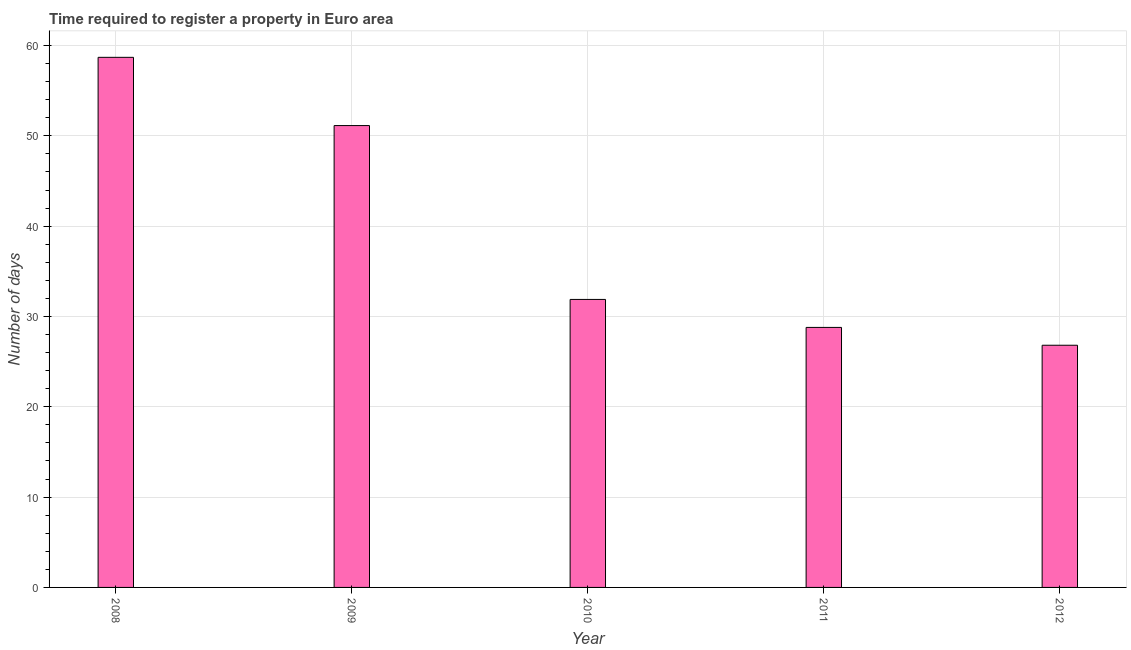Does the graph contain grids?
Your response must be concise. Yes. What is the title of the graph?
Make the answer very short. Time required to register a property in Euro area. What is the label or title of the Y-axis?
Your answer should be compact. Number of days. What is the number of days required to register property in 2012?
Your answer should be compact. 26.82. Across all years, what is the maximum number of days required to register property?
Ensure brevity in your answer.  58.69. Across all years, what is the minimum number of days required to register property?
Provide a succinct answer. 26.82. In which year was the number of days required to register property maximum?
Your answer should be very brief. 2008. In which year was the number of days required to register property minimum?
Provide a short and direct response. 2012. What is the sum of the number of days required to register property?
Your answer should be compact. 197.33. What is the difference between the number of days required to register property in 2008 and 2011?
Your answer should be very brief. 29.91. What is the average number of days required to register property per year?
Keep it short and to the point. 39.47. What is the median number of days required to register property?
Your answer should be compact. 31.89. In how many years, is the number of days required to register property greater than 4 days?
Offer a very short reply. 5. Do a majority of the years between 2008 and 2011 (inclusive) have number of days required to register property greater than 30 days?
Give a very brief answer. Yes. What is the ratio of the number of days required to register property in 2011 to that in 2012?
Offer a terse response. 1.07. Is the number of days required to register property in 2010 less than that in 2012?
Provide a succinct answer. No. Is the difference between the number of days required to register property in 2008 and 2009 greater than the difference between any two years?
Your response must be concise. No. What is the difference between the highest and the second highest number of days required to register property?
Offer a very short reply. 7.56. Is the sum of the number of days required to register property in 2010 and 2012 greater than the maximum number of days required to register property across all years?
Your answer should be compact. Yes. What is the difference between the highest and the lowest number of days required to register property?
Make the answer very short. 31.88. In how many years, is the number of days required to register property greater than the average number of days required to register property taken over all years?
Ensure brevity in your answer.  2. How many bars are there?
Provide a short and direct response. 5. Are the values on the major ticks of Y-axis written in scientific E-notation?
Make the answer very short. No. What is the Number of days in 2008?
Your answer should be compact. 58.69. What is the Number of days of 2009?
Your response must be concise. 51.14. What is the Number of days in 2010?
Provide a short and direct response. 31.89. What is the Number of days in 2011?
Your answer should be compact. 28.79. What is the Number of days of 2012?
Your answer should be very brief. 26.82. What is the difference between the Number of days in 2008 and 2009?
Provide a succinct answer. 7.56. What is the difference between the Number of days in 2008 and 2010?
Give a very brief answer. 26.81. What is the difference between the Number of days in 2008 and 2011?
Offer a very short reply. 29.9. What is the difference between the Number of days in 2008 and 2012?
Give a very brief answer. 31.88. What is the difference between the Number of days in 2009 and 2010?
Provide a succinct answer. 19.25. What is the difference between the Number of days in 2009 and 2011?
Provide a succinct answer. 22.35. What is the difference between the Number of days in 2009 and 2012?
Your answer should be very brief. 24.32. What is the difference between the Number of days in 2010 and 2011?
Provide a short and direct response. 3.1. What is the difference between the Number of days in 2010 and 2012?
Provide a succinct answer. 5.07. What is the difference between the Number of days in 2011 and 2012?
Offer a very short reply. 1.97. What is the ratio of the Number of days in 2008 to that in 2009?
Your answer should be compact. 1.15. What is the ratio of the Number of days in 2008 to that in 2010?
Make the answer very short. 1.84. What is the ratio of the Number of days in 2008 to that in 2011?
Offer a terse response. 2.04. What is the ratio of the Number of days in 2008 to that in 2012?
Offer a very short reply. 2.19. What is the ratio of the Number of days in 2009 to that in 2010?
Your answer should be very brief. 1.6. What is the ratio of the Number of days in 2009 to that in 2011?
Ensure brevity in your answer.  1.78. What is the ratio of the Number of days in 2009 to that in 2012?
Provide a short and direct response. 1.91. What is the ratio of the Number of days in 2010 to that in 2011?
Your answer should be compact. 1.11. What is the ratio of the Number of days in 2010 to that in 2012?
Keep it short and to the point. 1.19. What is the ratio of the Number of days in 2011 to that in 2012?
Make the answer very short. 1.07. 